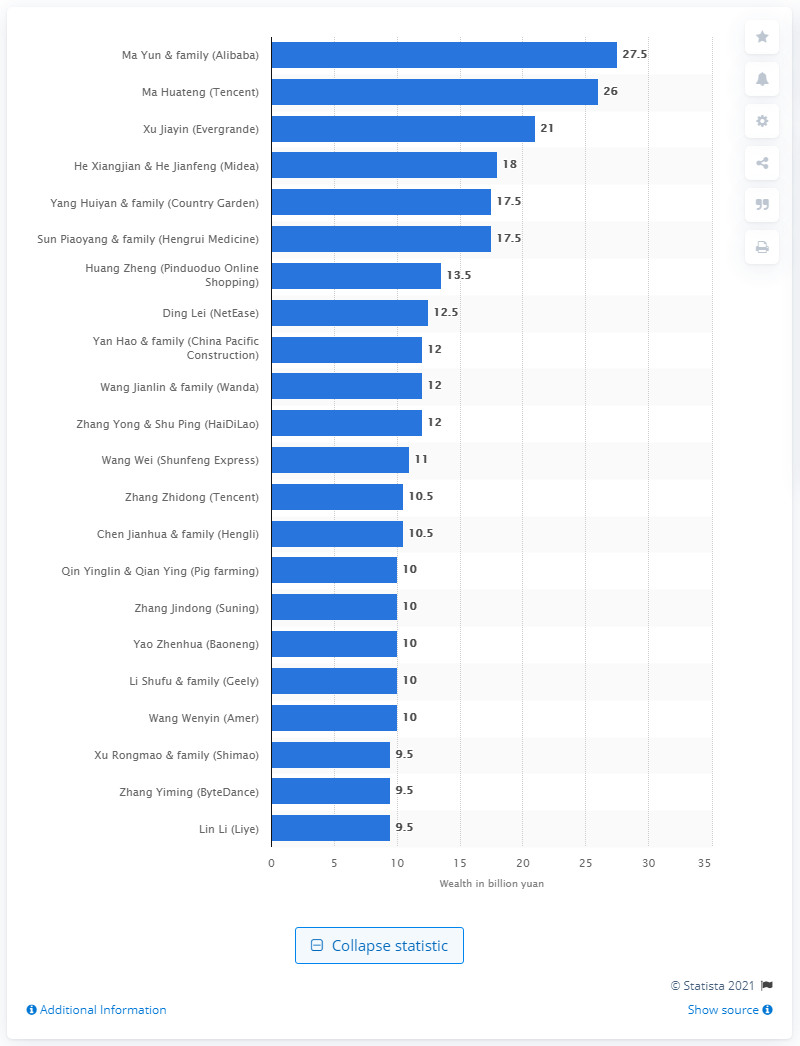Mention a couple of crucial points in this snapshot. In 2019, Ma Yun's net wealth was approximately 27.5 trillion dollars. 